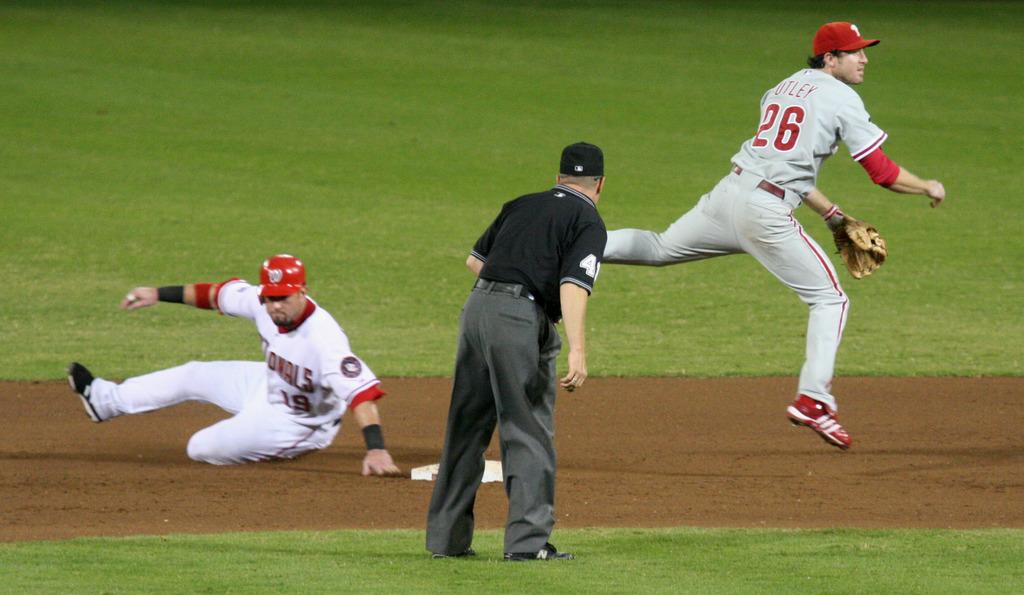What team are the players in?
Provide a short and direct response. Nationals. What is the right players number?
Keep it short and to the point. 26. 